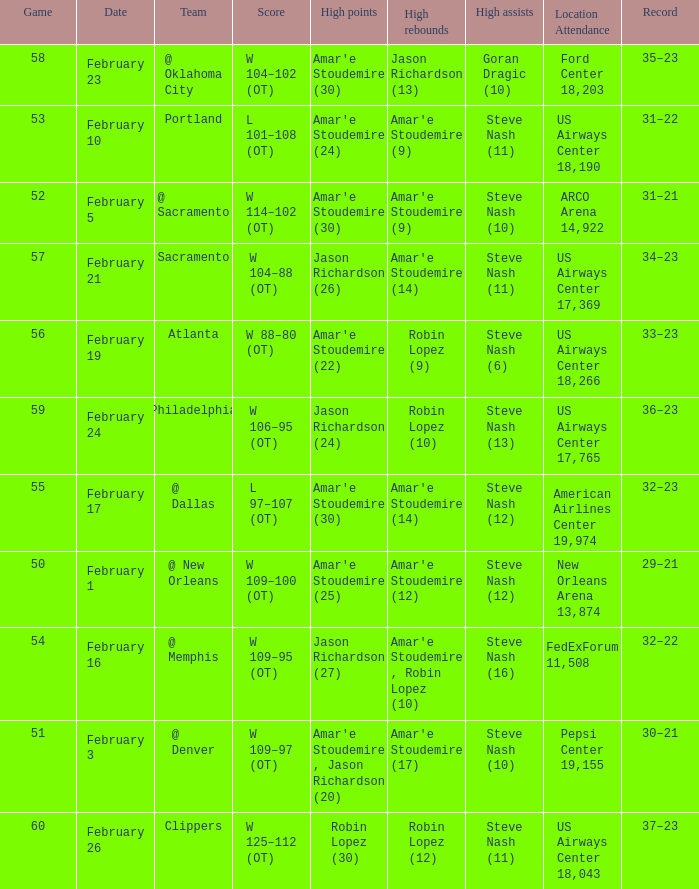Name the high points for pepsi center 19,155 Amar'e Stoudemire , Jason Richardson (20). 